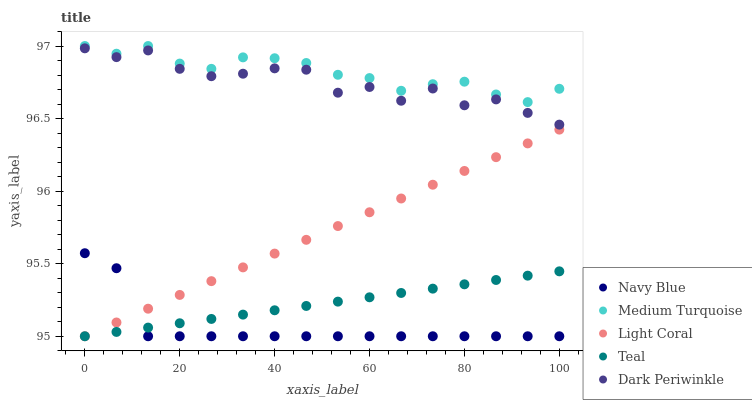Does Navy Blue have the minimum area under the curve?
Answer yes or no. Yes. Does Medium Turquoise have the maximum area under the curve?
Answer yes or no. Yes. Does Teal have the minimum area under the curve?
Answer yes or no. No. Does Teal have the maximum area under the curve?
Answer yes or no. No. Is Teal the smoothest?
Answer yes or no. Yes. Is Dark Periwinkle the roughest?
Answer yes or no. Yes. Is Navy Blue the smoothest?
Answer yes or no. No. Is Navy Blue the roughest?
Answer yes or no. No. Does Light Coral have the lowest value?
Answer yes or no. Yes. Does Medium Turquoise have the lowest value?
Answer yes or no. No. Does Medium Turquoise have the highest value?
Answer yes or no. Yes. Does Navy Blue have the highest value?
Answer yes or no. No. Is Light Coral less than Dark Periwinkle?
Answer yes or no. Yes. Is Medium Turquoise greater than Light Coral?
Answer yes or no. Yes. Does Light Coral intersect Navy Blue?
Answer yes or no. Yes. Is Light Coral less than Navy Blue?
Answer yes or no. No. Is Light Coral greater than Navy Blue?
Answer yes or no. No. Does Light Coral intersect Dark Periwinkle?
Answer yes or no. No. 